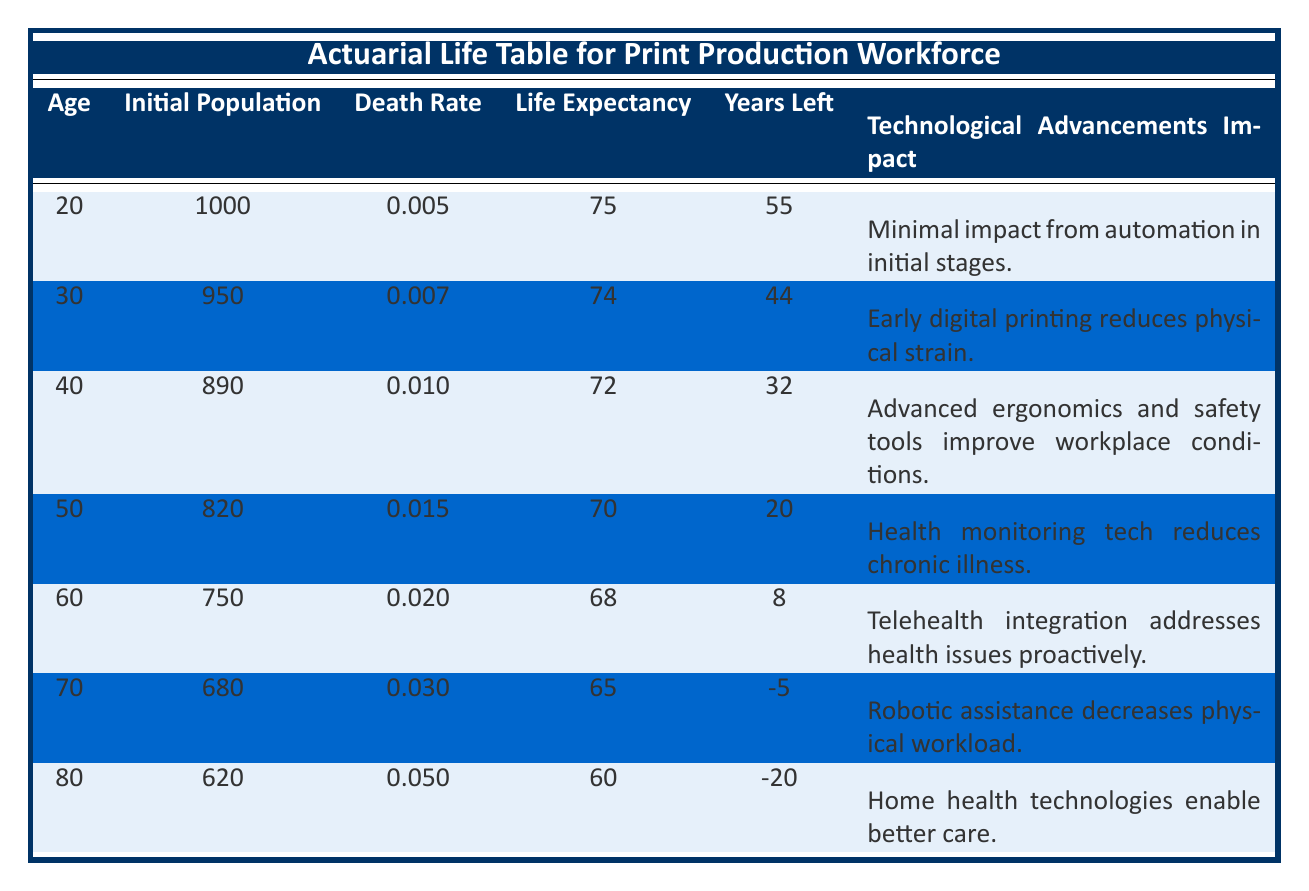What is the life expectancy of individuals aged 50? In the table, the entry for age 50 shows a life expectancy of 70 years.
Answer: 70 What impact do technological advancements have on the age group of 40? The table states that for the age group of 40, the impact of technological advancements is "Advanced ergonomics and safety tools improve workplace conditions."
Answer: Advanced ergonomics and safety tools improve workplace conditions What is the death rate for individuals aged 60? According to the table, the death rate for the age group of 60 is 0.020.
Answer: 0.020 Is the impact of technological advancements on individuals aged 70 described as significant? The impact for the age group of 70 is related to robotic assistance decreasing physical workload. This suggests a positive impact rather than significant negative impact.
Answer: No Calculate the average life expectancy of individuals aged 20, 30, and 40. The life expectancies for these age groups are 75, 74, and 72. Adding these gives 75 + 74 + 72 = 221. Dividing by 3 gives an average of 221/3 = approximately 73.67.
Answer: 73.67 What is the percentage decrease in life expectancy from age 20 to age 80? The life expectancy at age 20 is 75, and at age 80 it is 60. The decrease is 75 - 60 = 15 years. To find the percentage decrease, we divide by the original value: (15 / 75) * 100 = 20%.
Answer: 20% What is the difference in initial population between the age groups of 30 and 50? The initial population for age 30 is 950, and for age 50 it is 820. The difference is calculated by subtracting the two values: 950 - 820 = 130.
Answer: 130 How many individuals are predicted to remain at age 70? The initial population for age 70 is 680. According to the table, this is the number of individuals predicted to remain in this group.
Answer: 680 What does the table indicate about health technology's impact on individuals aged 60? The table notes that for age 60, telehealth integration addresses health issues proactively, indicating a positive response to advancements in health technology.
Answer: Positive impact 